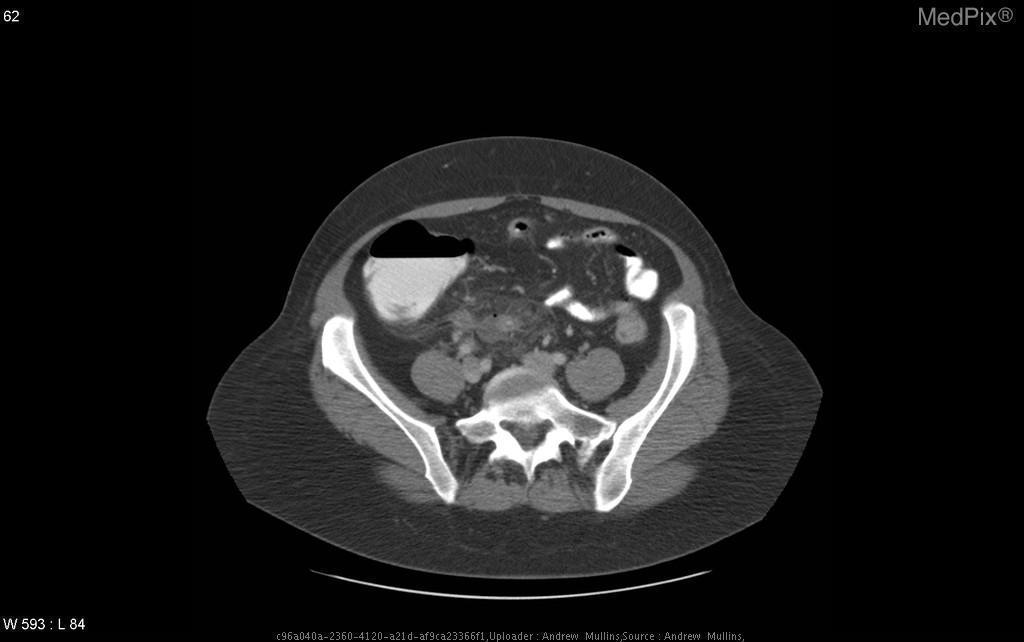What is most alarming about the appendix?
Give a very brief answer. Extraluminal air and small fluid collection. Describe the appendix
Answer briefly. Enlarged, fluid-filled. Is there fat stranding?
Answer briefly. Yes. 